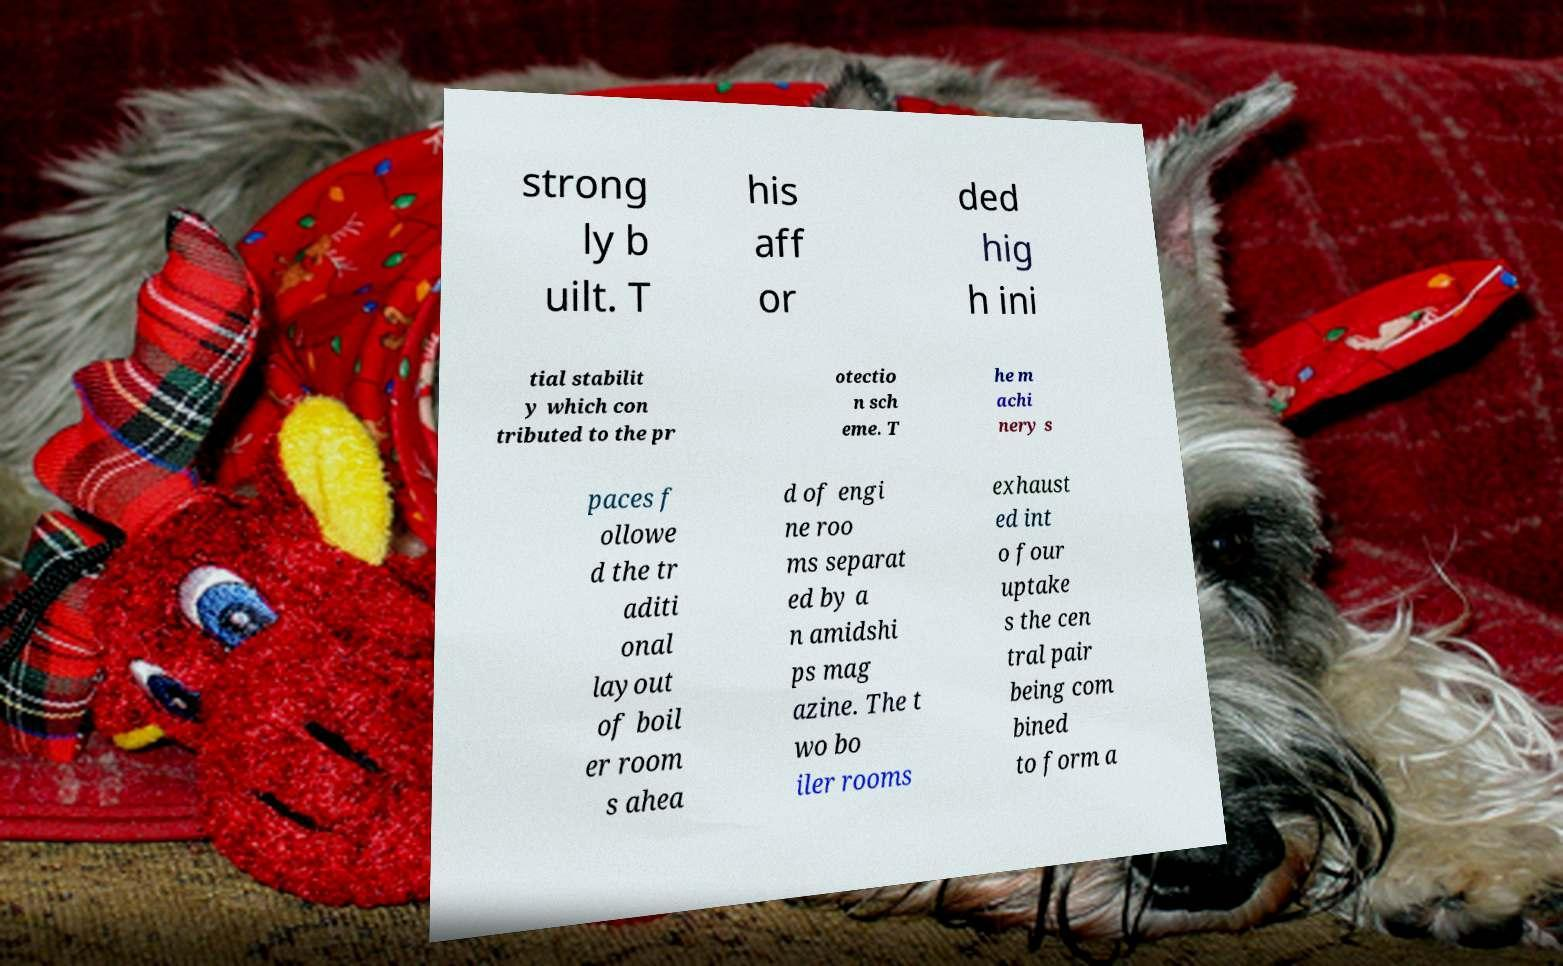Can you accurately transcribe the text from the provided image for me? strong ly b uilt. T his aff or ded hig h ini tial stabilit y which con tributed to the pr otectio n sch eme. T he m achi nery s paces f ollowe d the tr aditi onal layout of boil er room s ahea d of engi ne roo ms separat ed by a n amidshi ps mag azine. The t wo bo iler rooms exhaust ed int o four uptake s the cen tral pair being com bined to form a 